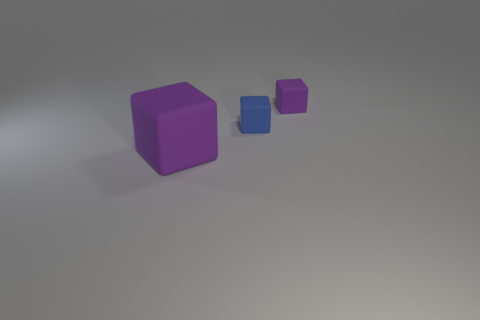Subtract all tiny matte cubes. How many cubes are left? 1 Add 2 tiny purple things. How many objects exist? 5 Subtract all purple spheres. How many purple blocks are left? 2 Subtract 1 blocks. How many blocks are left? 2 Subtract all blue blocks. How many blocks are left? 2 Subtract all blue blocks. Subtract all green balls. How many blocks are left? 2 Subtract all matte objects. Subtract all cyan shiny objects. How many objects are left? 0 Add 3 purple matte cubes. How many purple matte cubes are left? 5 Add 1 green cylinders. How many green cylinders exist? 1 Subtract 0 red cubes. How many objects are left? 3 